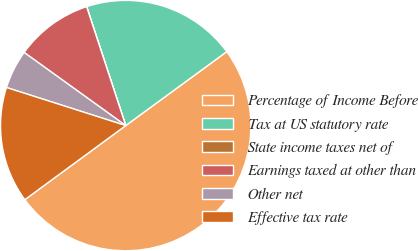Convert chart to OTSL. <chart><loc_0><loc_0><loc_500><loc_500><pie_chart><fcel>Percentage of Income Before<fcel>Tax at US statutory rate<fcel>State income taxes net of<fcel>Earnings taxed at other than<fcel>Other net<fcel>Effective tax rate<nl><fcel>49.97%<fcel>20.0%<fcel>0.01%<fcel>10.01%<fcel>5.01%<fcel>15.0%<nl></chart> 